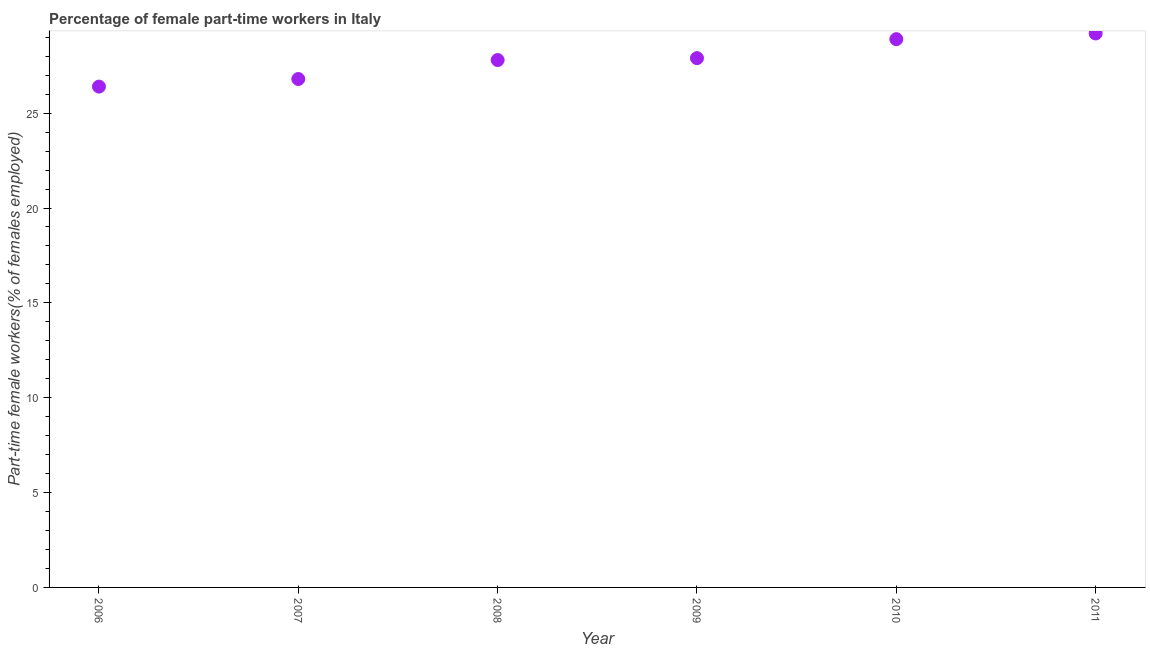What is the percentage of part-time female workers in 2010?
Your answer should be very brief. 28.9. Across all years, what is the maximum percentage of part-time female workers?
Offer a very short reply. 29.2. Across all years, what is the minimum percentage of part-time female workers?
Give a very brief answer. 26.4. In which year was the percentage of part-time female workers minimum?
Make the answer very short. 2006. What is the sum of the percentage of part-time female workers?
Provide a short and direct response. 167. What is the difference between the percentage of part-time female workers in 2008 and 2011?
Keep it short and to the point. -1.4. What is the average percentage of part-time female workers per year?
Your answer should be compact. 27.83. What is the median percentage of part-time female workers?
Your answer should be very brief. 27.85. In how many years, is the percentage of part-time female workers greater than 10 %?
Ensure brevity in your answer.  6. Do a majority of the years between 2009 and 2010 (inclusive) have percentage of part-time female workers greater than 23 %?
Offer a terse response. Yes. What is the ratio of the percentage of part-time female workers in 2007 to that in 2010?
Make the answer very short. 0.93. Is the percentage of part-time female workers in 2006 less than that in 2007?
Ensure brevity in your answer.  Yes. What is the difference between the highest and the second highest percentage of part-time female workers?
Your response must be concise. 0.3. What is the difference between the highest and the lowest percentage of part-time female workers?
Offer a terse response. 2.8. Does the percentage of part-time female workers monotonically increase over the years?
Offer a terse response. Yes. How many years are there in the graph?
Give a very brief answer. 6. What is the title of the graph?
Provide a short and direct response. Percentage of female part-time workers in Italy. What is the label or title of the Y-axis?
Ensure brevity in your answer.  Part-time female workers(% of females employed). What is the Part-time female workers(% of females employed) in 2006?
Your response must be concise. 26.4. What is the Part-time female workers(% of females employed) in 2007?
Your response must be concise. 26.8. What is the Part-time female workers(% of females employed) in 2008?
Offer a terse response. 27.8. What is the Part-time female workers(% of females employed) in 2009?
Give a very brief answer. 27.9. What is the Part-time female workers(% of females employed) in 2010?
Your response must be concise. 28.9. What is the Part-time female workers(% of females employed) in 2011?
Provide a short and direct response. 29.2. What is the difference between the Part-time female workers(% of females employed) in 2006 and 2008?
Give a very brief answer. -1.4. What is the difference between the Part-time female workers(% of females employed) in 2006 and 2011?
Give a very brief answer. -2.8. What is the difference between the Part-time female workers(% of females employed) in 2007 and 2008?
Give a very brief answer. -1. What is the difference between the Part-time female workers(% of females employed) in 2007 and 2009?
Your answer should be very brief. -1.1. What is the difference between the Part-time female workers(% of females employed) in 2007 and 2010?
Your response must be concise. -2.1. What is the difference between the Part-time female workers(% of females employed) in 2008 and 2010?
Make the answer very short. -1.1. What is the difference between the Part-time female workers(% of females employed) in 2008 and 2011?
Offer a terse response. -1.4. What is the difference between the Part-time female workers(% of females employed) in 2009 and 2010?
Your response must be concise. -1. What is the ratio of the Part-time female workers(% of females employed) in 2006 to that in 2009?
Offer a terse response. 0.95. What is the ratio of the Part-time female workers(% of females employed) in 2006 to that in 2010?
Offer a terse response. 0.91. What is the ratio of the Part-time female workers(% of females employed) in 2006 to that in 2011?
Your answer should be compact. 0.9. What is the ratio of the Part-time female workers(% of females employed) in 2007 to that in 2008?
Your response must be concise. 0.96. What is the ratio of the Part-time female workers(% of females employed) in 2007 to that in 2010?
Your answer should be very brief. 0.93. What is the ratio of the Part-time female workers(% of females employed) in 2007 to that in 2011?
Offer a very short reply. 0.92. What is the ratio of the Part-time female workers(% of females employed) in 2008 to that in 2009?
Offer a very short reply. 1. What is the ratio of the Part-time female workers(% of females employed) in 2008 to that in 2010?
Provide a succinct answer. 0.96. What is the ratio of the Part-time female workers(% of females employed) in 2008 to that in 2011?
Ensure brevity in your answer.  0.95. What is the ratio of the Part-time female workers(% of females employed) in 2009 to that in 2010?
Your answer should be compact. 0.96. What is the ratio of the Part-time female workers(% of females employed) in 2009 to that in 2011?
Give a very brief answer. 0.95. 